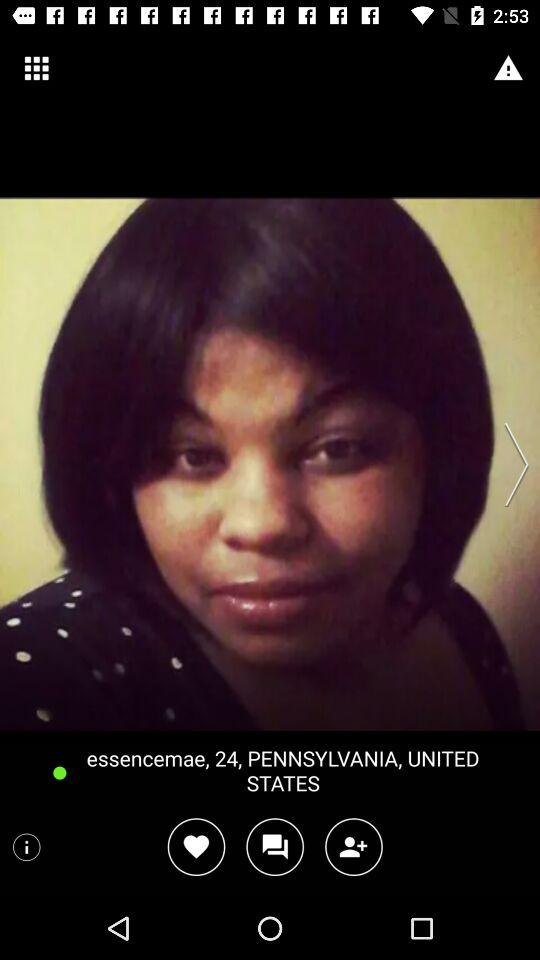What is the given username? The given username is "essencemae". 